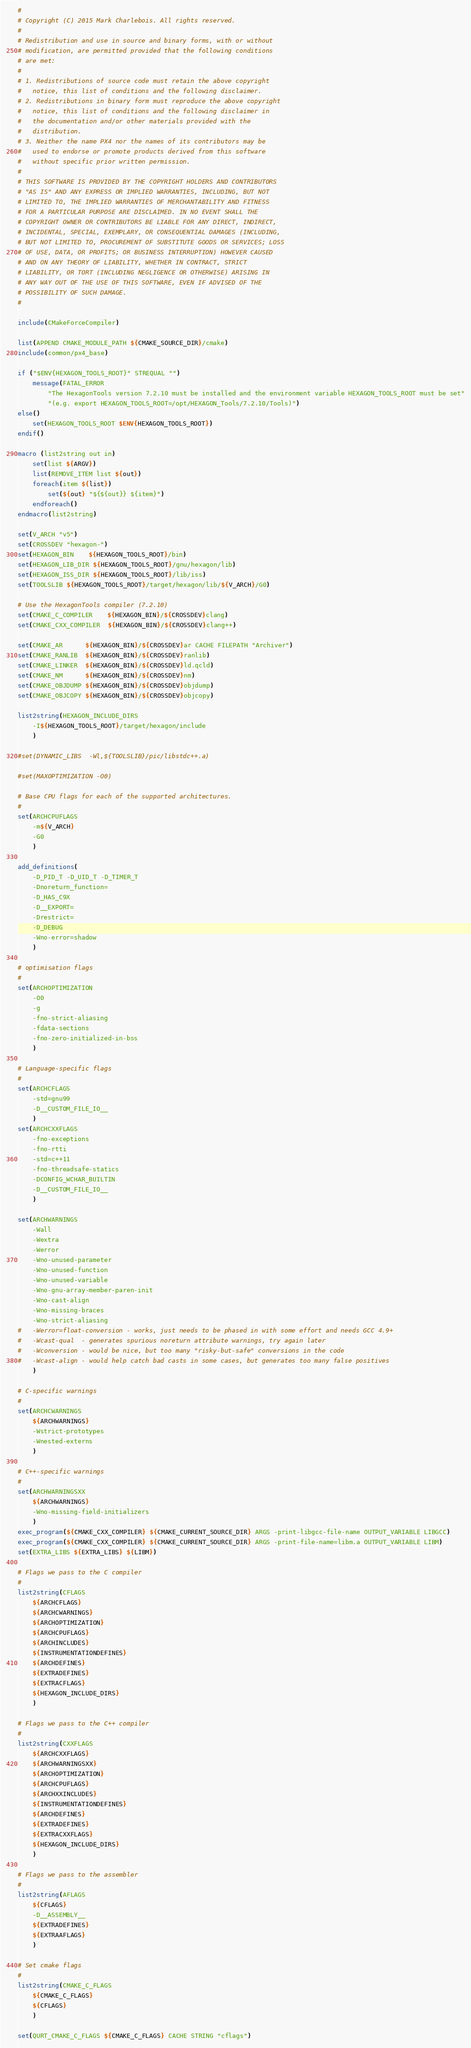Convert code to text. <code><loc_0><loc_0><loc_500><loc_500><_CMake_>#
# Copyright (C) 2015 Mark Charlebois. All rights reserved.
#
# Redistribution and use in source and binary forms, with or without
# modification, are permitted provided that the following conditions
# are met:
#
# 1. Redistributions of source code must retain the above copyright
#	notice, this list of conditions and the following disclaimer.
# 2. Redistributions in binary form must reproduce the above copyright
#	notice, this list of conditions and the following disclaimer in
#	the documentation and/or other materials provided with the
#	distribution.
# 3. Neither the name PX4 nor the names of its contributors may be
#	used to endorse or promote products derived from this software
#	without specific prior written permission.
#
# THIS SOFTWARE IS PROVIDED BY THE COPYRIGHT HOLDERS AND CONTRIBUTORS
# "AS IS" AND ANY EXPRESS OR IMPLIED WARRANTIES, INCLUDING, BUT NOT
# LIMITED TO, THE IMPLIED WARRANTIES OF MERCHANTABILITY AND FITNESS
# FOR A PARTICULAR PURPOSE ARE DISCLAIMED. IN NO EVENT SHALL THE
# COPYRIGHT OWNER OR CONTRIBUTORS BE LIABLE FOR ANY DIRECT, INDIRECT,
# INCIDENTAL, SPECIAL, EXEMPLARY, OR CONSEQUENTIAL DAMAGES (INCLUDING,
# BUT NOT LIMITED TO, PROCUREMENT OF SUBSTITUTE GOODS OR SERVICES; LOSS
# OF USE, DATA, OR PROFITS; OR BUSINESS INTERRUPTION) HOWEVER CAUSED
# AND ON ANY THEORY OF LIABILITY, WHETHER IN CONTRACT, STRICT
# LIABILITY, OR TORT (INCLUDING NEGLIGENCE OR OTHERWISE) ARISING IN
# ANY WAY OUT OF THE USE OF THIS SOFTWARE, EVEN IF ADVISED OF THE
# POSSIBILITY OF SUCH DAMAGE.
#

include(CMakeForceCompiler)

list(APPEND CMAKE_MODULE_PATH ${CMAKE_SOURCE_DIR}/cmake)
include(common/px4_base)

if ("$ENV{HEXAGON_TOOLS_ROOT}" STREQUAL "")
	message(FATAL_ERROR
		"The HexagonTools version 7.2.10 must be installed and the environment variable HEXAGON_TOOLS_ROOT must be set"
		"(e.g. export HEXAGON_TOOLS_ROOT=/opt/HEXAGON_Tools/7.2.10/Tools)")
else()
	set(HEXAGON_TOOLS_ROOT $ENV{HEXAGON_TOOLS_ROOT})
endif()

macro (list2string out in)
	set(list ${ARGV})
	list(REMOVE_ITEM list ${out})
	foreach(item ${list})
		set(${out} "${${out}} ${item}")
	endforeach()
endmacro(list2string)

set(V_ARCH "v5")
set(CROSSDEV "hexagon-")
set(HEXAGON_BIN	${HEXAGON_TOOLS_ROOT}/bin)
set(HEXAGON_LIB_DIR ${HEXAGON_TOOLS_ROOT}/gnu/hexagon/lib)
set(HEXAGON_ISS_DIR ${HEXAGON_TOOLS_ROOT}/lib/iss)
set(TOOLSLIB ${HEXAGON_TOOLS_ROOT}/target/hexagon/lib/${V_ARCH}/G0)

# Use the HexagonTools compiler (7.2.10)
set(CMAKE_C_COMPILER	${HEXAGON_BIN}/${CROSSDEV}clang)
set(CMAKE_CXX_COMPILER  ${HEXAGON_BIN}/${CROSSDEV}clang++)

set(CMAKE_AR	  ${HEXAGON_BIN}/${CROSSDEV}ar CACHE FILEPATH "Archiver")
set(CMAKE_RANLIB  ${HEXAGON_BIN}/${CROSSDEV}ranlib)
set(CMAKE_LINKER  ${HEXAGON_BIN}/${CROSSDEV}ld.qcld)
set(CMAKE_NM	  ${HEXAGON_BIN}/${CROSSDEV}nm)
set(CMAKE_OBJDUMP ${HEXAGON_BIN}/${CROSSDEV}objdump)
set(CMAKE_OBJCOPY ${HEXAGON_BIN}/${CROSSDEV}objcopy)

list2string(HEXAGON_INCLUDE_DIRS 
	-I${HEXAGON_TOOLS_ROOT}/target/hexagon/include
	)

#set(DYNAMIC_LIBS  -Wl,${TOOLSLIB}/pic/libstdc++.a)

#set(MAXOPTIMIZATION -O0)

# Base CPU flags for each of the supported architectures.
#
set(ARCHCPUFLAGS
	-m${V_ARCH}
	-G0
	)

add_definitions(
	-D_PID_T -D_UID_T -D_TIMER_T
	-Dnoreturn_function= 
	-D_HAS_C9X
	-D__EXPORT= 
	-Drestrict=
	-D_DEBUG
	-Wno-error=shadow
	)

# optimisation flags
#
set(ARCHOPTIMIZATION
	-O0
	-g
	-fno-strict-aliasing
	-fdata-sections
	-fno-zero-initialized-in-bss
	)

# Language-specific flags
#
set(ARCHCFLAGS
	-std=gnu99
	-D__CUSTOM_FILE_IO__
	)
set(ARCHCXXFLAGS
	-fno-exceptions
	-fno-rtti
	-std=c++11
	-fno-threadsafe-statics
	-DCONFIG_WCHAR_BUILTIN
	-D__CUSTOM_FILE_IO__
	)

set(ARCHWARNINGS
	-Wall
	-Wextra
	-Werror
	-Wno-unused-parameter
	-Wno-unused-function
	-Wno-unused-variable
	-Wno-gnu-array-member-paren-init
	-Wno-cast-align
	-Wno-missing-braces
	-Wno-strict-aliasing
#   -Werror=float-conversion - works, just needs to be phased in with some effort and needs GCC 4.9+
#   -Wcast-qual  - generates spurious noreturn attribute warnings, try again later
#   -Wconversion - would be nice, but too many "risky-but-safe" conversions in the code
#   -Wcast-align - would help catch bad casts in some cases, but generates too many false positives
	)

# C-specific warnings
#
set(ARCHCWARNINGS
	${ARCHWARNINGS}
	-Wstrict-prototypes
	-Wnested-externs
	)

# C++-specific warnings
#
set(ARCHWARNINGSXX
	${ARCHWARNINGS}
	-Wno-missing-field-initializers
	)
exec_program(${CMAKE_CXX_COMPILER} ${CMAKE_CURRENT_SOURCE_DIR} ARGS -print-libgcc-file-name OUTPUT_VARIABLE LIBGCC)
exec_program(${CMAKE_CXX_COMPILER} ${CMAKE_CURRENT_SOURCE_DIR} ARGS -print-file-name=libm.a OUTPUT_VARIABLE LIBM)
set(EXTRA_LIBS ${EXTRA_LIBS} ${LIBM})

# Flags we pass to the C compiler
#
list2string(CFLAGS 
	${ARCHCFLAGS}
	${ARCHCWARNINGS}
	${ARCHOPTIMIZATION}
	${ARCHCPUFLAGS}
	${ARCHINCLUDES}
	${INSTRUMENTATIONDEFINES}
	${ARCHDEFINES}
	${EXTRADEFINES}
	${EXTRACFLAGS}
	${HEXAGON_INCLUDE_DIRS}
	)

# Flags we pass to the C++ compiler
#
list2string(CXXFLAGS
	${ARCHCXXFLAGS}
	${ARCHWARNINGSXX}
	${ARCHOPTIMIZATION}
	${ARCHCPUFLAGS}
	${ARCHXXINCLUDES}
	${INSTRUMENTATIONDEFINES}
	${ARCHDEFINES}
	${EXTRADEFINES}
	${EXTRACXXFLAGS}
	${HEXAGON_INCLUDE_DIRS}
	)

# Flags we pass to the assembler
#
list2string(AFLAGS
	${CFLAGS} 
	-D__ASSEMBLY__
	${EXTRADEFINES}
	${EXTRAAFLAGS}
	)

# Set cmake flags
#
list2string(CMAKE_C_FLAGS
	${CMAKE_C_FLAGS}
	${CFLAGS}
	)

set(QURT_CMAKE_C_FLAGS ${CMAKE_C_FLAGS} CACHE STRING "cflags")
</code> 